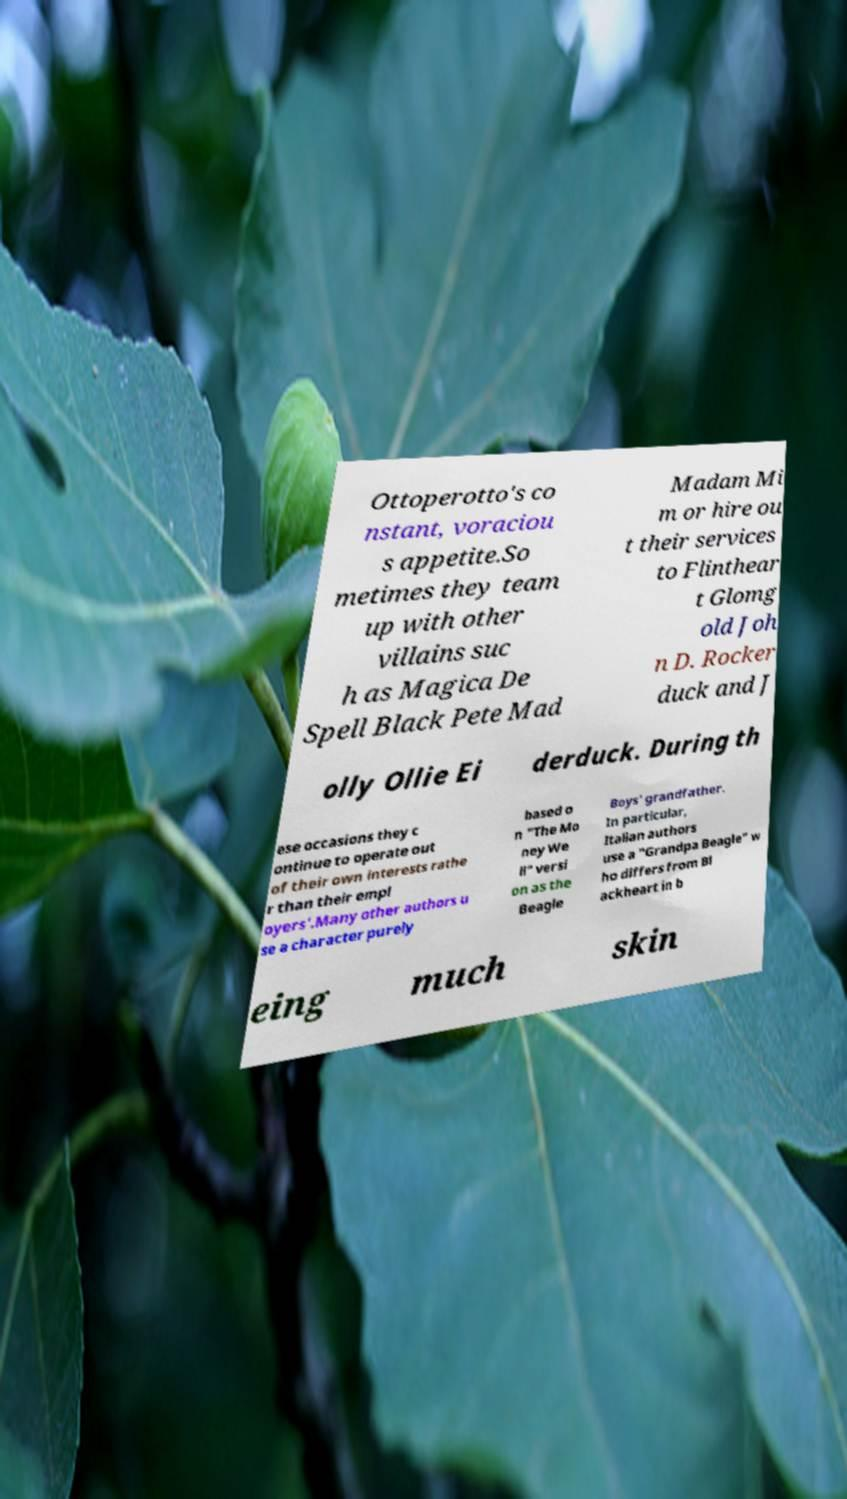Could you extract and type out the text from this image? Ottoperotto's co nstant, voraciou s appetite.So metimes they team up with other villains suc h as Magica De Spell Black Pete Mad Madam Mi m or hire ou t their services to Flinthear t Glomg old Joh n D. Rocker duck and J olly Ollie Ei derduck. During th ese occasions they c ontinue to operate out of their own interests rathe r than their empl oyers'.Many other authors u se a character purely based o n "The Mo ney We ll" versi on as the Beagle Boys' grandfather. In particular, Italian authors use a "Grandpa Beagle" w ho differs from Bl ackheart in b eing much skin 